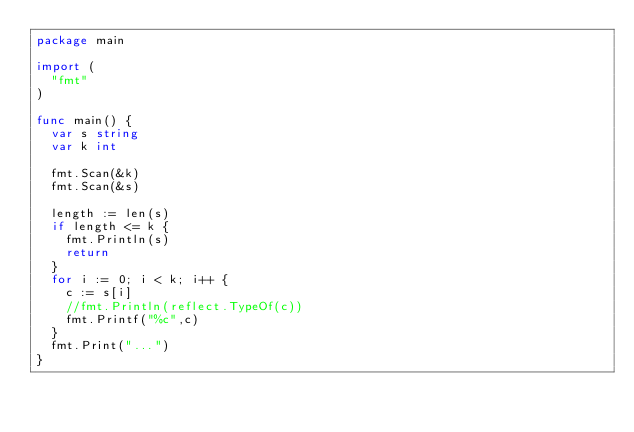Convert code to text. <code><loc_0><loc_0><loc_500><loc_500><_Go_>package main

import (
	"fmt"
)

func main() {
	var s string
	var k int

	fmt.Scan(&k)
	fmt.Scan(&s)

	length := len(s)
	if length <= k {
		fmt.Println(s)
		return
	}
	for i := 0; i < k; i++ {
		c := s[i]
		//fmt.Println(reflect.TypeOf(c))
		fmt.Printf("%c",c)
	}
	fmt.Print("...")
}</code> 